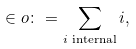<formula> <loc_0><loc_0><loc_500><loc_500>\in o \colon = \sum _ { i \text { internal} } i ,</formula> 